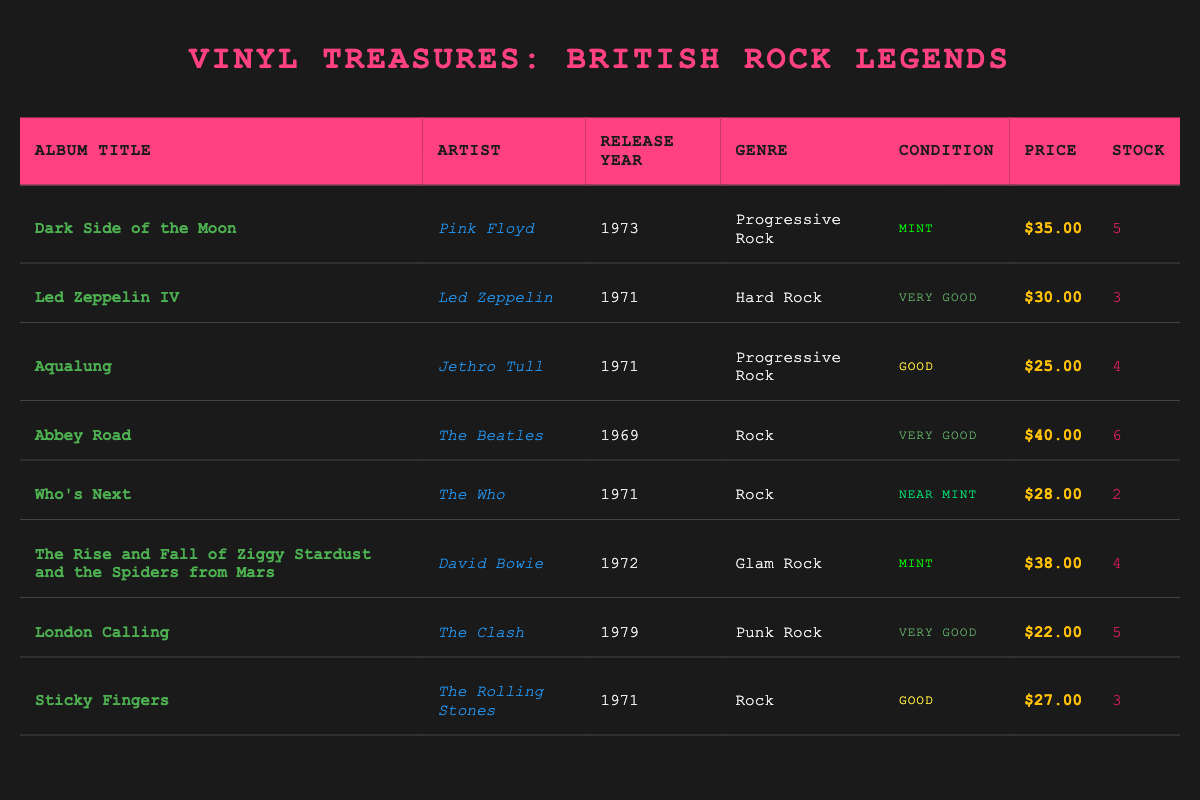What is the price of "Abbey Road"? According to the table, "Abbey Road" by The Beatles is listed under the price column as $40.00.
Answer: $40.00 How many copies of "Who's Next" are in stock? The table shows that there are 2 copies of "Who's Next" by The Who in the stock quantity column.
Answer: 2 Which album has the highest price? By reviewing the price column, "Abbey Road" at $40.00 is the highest, compared to the other albums listed.
Answer: $40.00 What is the average price of the albums in stock? To calculate the average, we sum the prices: (35 + 30 + 25 + 40 + 28 + 38 + 22 + 27) = 305. There are 8 albums, so the average price is 305 / 8 = 38.125, which rounds to $38.13.
Answer: $38.13 Is "London Calling" in near mint condition? The condition of "London Calling" is listed as "Very Good" in the table, so it is not in near mint condition.
Answer: No Which artist has the most albums listed? The table includes one album each from Pink Floyd, Led Zeppelin, Jethro Tull, The Beatles, The Who, David Bowie, The Clash, and The Rolling Stones, totaling 8 artists. There is no artist with more than one album listed.
Answer: No artist has more than one album What is the total stock quantity of albums in mint condition? From the table, the albums in mint condition are "Dark Side of the Moon" (5 copies) and "The Rise and Fall of Ziggy Stardust" (4 copies), adding them together gives 5 + 4 = 9.
Answer: 9 Which album was released in 1971 but is not in mint condition? The albums released in 1971 are "Led Zeppelin IV" (Very Good), "Aqualung" (Good), and "Who's Next" (Near Mint). Removing the mint condition leaves "Led Zeppelin IV" and "Aqualung".
Answer: Led Zeppelin IV and Aqualung How many total albums are listed from the 1970s? Looking at the release years, the albums from the 1970s are "Led Zeppelin IV" (1971), "Aqualung" (1971), "Who's Next" (1971), "The Rise and Fall of Ziggy Stardust" (1972), "London Calling" (1979). A total of 5 albums are from the 1970s.
Answer: 5 